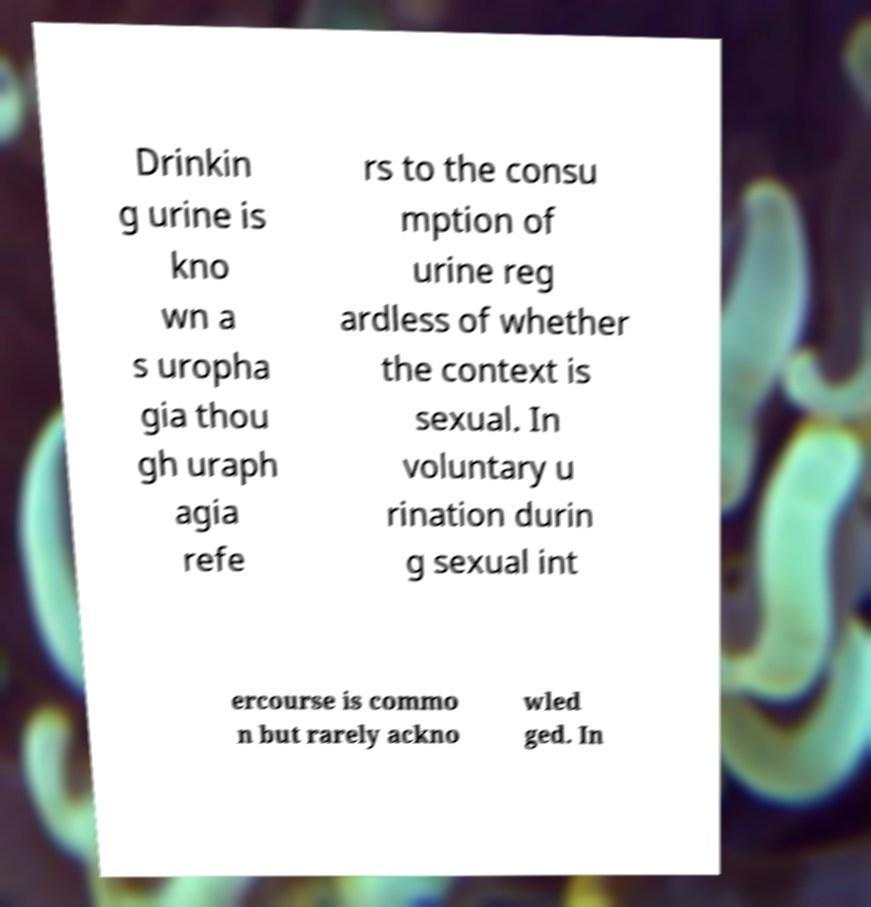Can you accurately transcribe the text from the provided image for me? Drinkin g urine is kno wn a s uropha gia thou gh uraph agia refe rs to the consu mption of urine reg ardless of whether the context is sexual. In voluntary u rination durin g sexual int ercourse is commo n but rarely ackno wled ged. In 